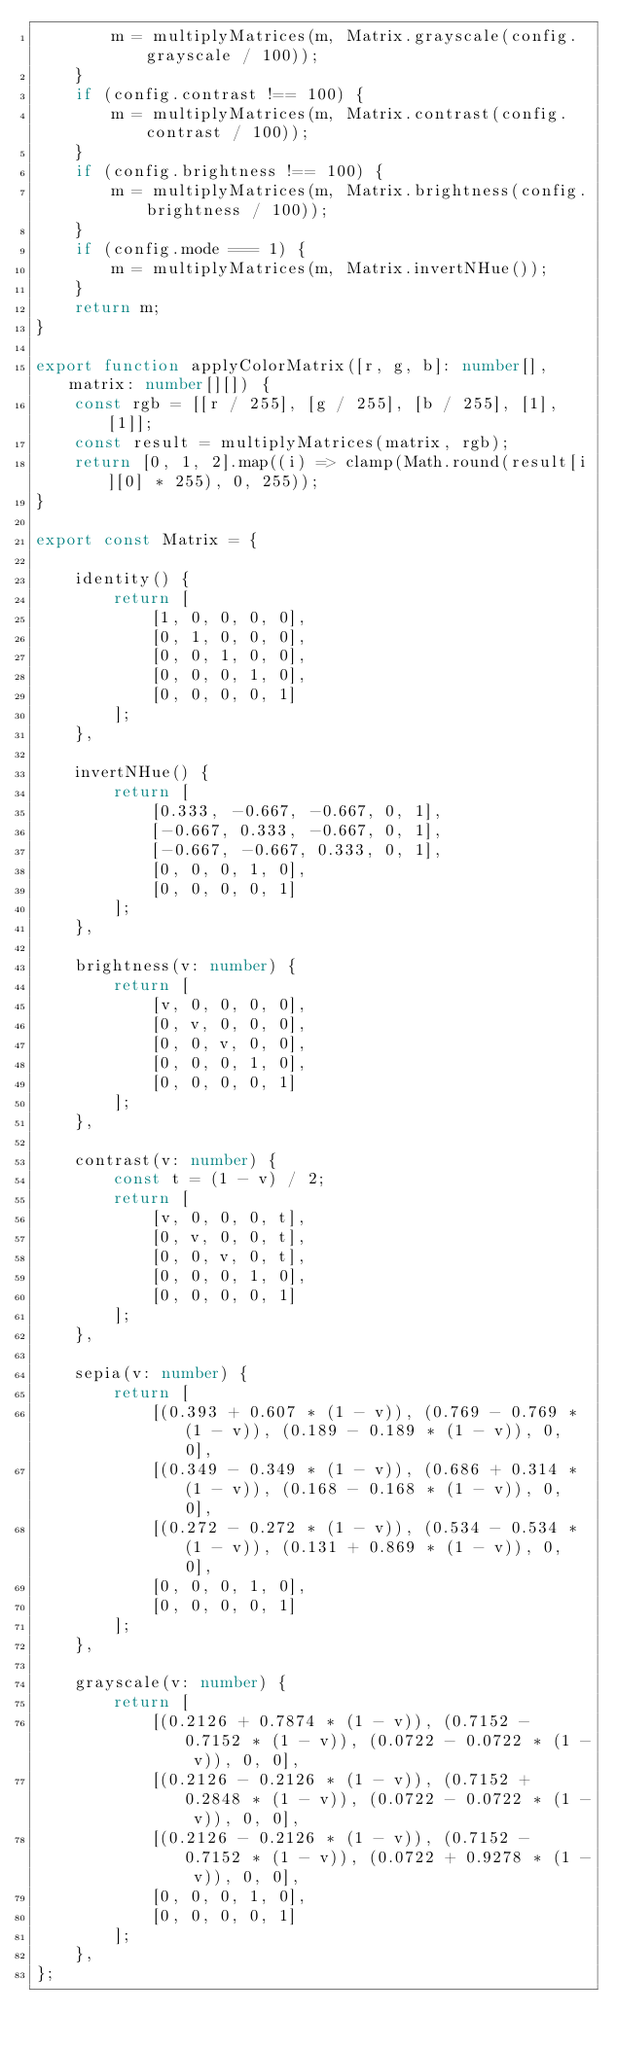<code> <loc_0><loc_0><loc_500><loc_500><_TypeScript_>        m = multiplyMatrices(m, Matrix.grayscale(config.grayscale / 100));
    }
    if (config.contrast !== 100) {
        m = multiplyMatrices(m, Matrix.contrast(config.contrast / 100));
    }
    if (config.brightness !== 100) {
        m = multiplyMatrices(m, Matrix.brightness(config.brightness / 100));
    }
    if (config.mode === 1) {
        m = multiplyMatrices(m, Matrix.invertNHue());
    }
    return m;
}

export function applyColorMatrix([r, g, b]: number[], matrix: number[][]) {
    const rgb = [[r / 255], [g / 255], [b / 255], [1], [1]];
    const result = multiplyMatrices(matrix, rgb);
    return [0, 1, 2].map((i) => clamp(Math.round(result[i][0] * 255), 0, 255));
}

export const Matrix = {

    identity() {
        return [
            [1, 0, 0, 0, 0],
            [0, 1, 0, 0, 0],
            [0, 0, 1, 0, 0],
            [0, 0, 0, 1, 0],
            [0, 0, 0, 0, 1]
        ];
    },

    invertNHue() {
        return [
            [0.333, -0.667, -0.667, 0, 1],
            [-0.667, 0.333, -0.667, 0, 1],
            [-0.667, -0.667, 0.333, 0, 1],
            [0, 0, 0, 1, 0],
            [0, 0, 0, 0, 1]
        ];
    },

    brightness(v: number) {
        return [
            [v, 0, 0, 0, 0],
            [0, v, 0, 0, 0],
            [0, 0, v, 0, 0],
            [0, 0, 0, 1, 0],
            [0, 0, 0, 0, 1]
        ];
    },

    contrast(v: number) {
        const t = (1 - v) / 2;
        return [
            [v, 0, 0, 0, t],
            [0, v, 0, 0, t],
            [0, 0, v, 0, t],
            [0, 0, 0, 1, 0],
            [0, 0, 0, 0, 1]
        ];
    },

    sepia(v: number) {
        return [
            [(0.393 + 0.607 * (1 - v)), (0.769 - 0.769 * (1 - v)), (0.189 - 0.189 * (1 - v)), 0, 0],
            [(0.349 - 0.349 * (1 - v)), (0.686 + 0.314 * (1 - v)), (0.168 - 0.168 * (1 - v)), 0, 0],
            [(0.272 - 0.272 * (1 - v)), (0.534 - 0.534 * (1 - v)), (0.131 + 0.869 * (1 - v)), 0, 0],
            [0, 0, 0, 1, 0],
            [0, 0, 0, 0, 1]
        ];
    },

    grayscale(v: number) {
        return [
            [(0.2126 + 0.7874 * (1 - v)), (0.7152 - 0.7152 * (1 - v)), (0.0722 - 0.0722 * (1 - v)), 0, 0],
            [(0.2126 - 0.2126 * (1 - v)), (0.7152 + 0.2848 * (1 - v)), (0.0722 - 0.0722 * (1 - v)), 0, 0],
            [(0.2126 - 0.2126 * (1 - v)), (0.7152 - 0.7152 * (1 - v)), (0.0722 + 0.9278 * (1 - v)), 0, 0],
            [0, 0, 0, 1, 0],
            [0, 0, 0, 0, 1]
        ];
    },
};
</code> 